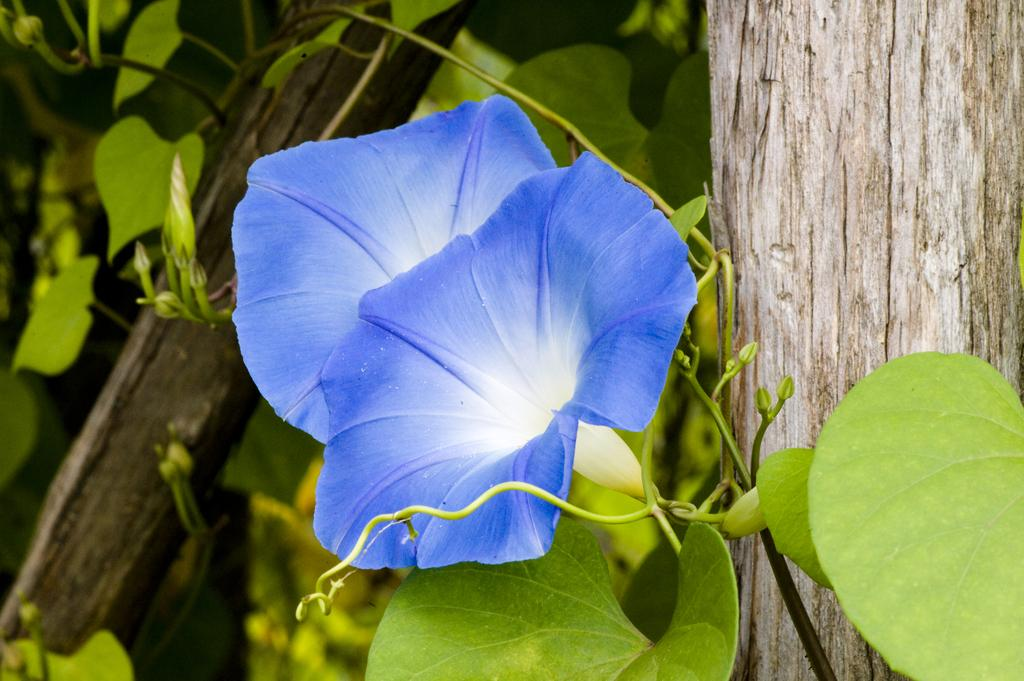What type of plant is visible in the image? There are flowers on a plant in the image. What material are the planks made of in the image? The wooden planks present in the image are made of wood. What type of pollution can be seen in the image? There is no pollution visible in the image. Is there a hole in the wooden planks in the image? The provided facts do not mention any holes in the wooden planks, so we cannot determine if there is a hole or not. 